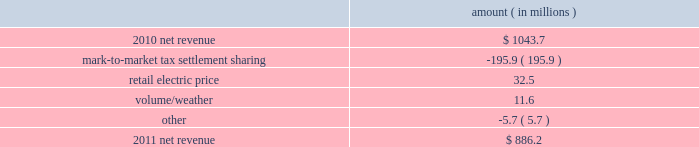Entergy louisiana , llc and subsidiaries management 2019s financial discussion and analysis plan to spin off the utility 2019s transmission business see the 201cplan to spin off the utility 2019s transmission business 201d section of entergy corporation and subsidiaries management 2019s financial discussion and analysis for a discussion of this matter , including the planned retirement of debt and preferred securities .
Results of operations net income 2011 compared to 2010 net income increased $ 242.5 million primarily due to a settlement with the irs related to the mark-to-market income tax treatment of power purchase contracts , which resulted in a $ 422 million income tax benefit .
The net income effect was partially offset by a $ 199 million regulatory charge , which reduced net revenue , because a portion of the benefit will be shared with customers .
See note 3 to the financial statements for additional discussion of the settlement and benefit sharing .
2010 compared to 2009 net income decreased slightly by $ 1.4 million primarily due to higher other operation and maintenance expenses , a higher effective income tax rate , and higher interest expense , almost entirely offset by higher net revenue .
Net revenue 2011 compared to 2010 net revenue consists of operating revenues net of : 1 ) fuel , fuel-related expenses , and gas purchased for resale , 2 ) purchased power expenses , and 3 ) other regulatory charges ( credits ) .
Following is an analysis of the change in net revenue comparing 2011 to 2010 .
Amount ( in millions ) .
The mark-to-market tax settlement sharing variance results from a regulatory charge because a portion of the benefits of a settlement with the irs related to the mark-to-market income tax treatment of power purchase contracts will be shared with customers , slightly offset by the amortization of a portion of that charge beginning in october 2011 .
See notes 3 and 8 to the financial statements for additional discussion of the settlement and benefit sharing .
The retail electric price variance is primarily due to a formula rate plan increase effective may 2011 .
See note 2 to the financial statements for discussion of the formula rate plan increase. .
In 2011 what was the ratio of the income tax benefit to the increase in the net income? 
Computations: (422 / 242.5)
Answer: 1.74021. 